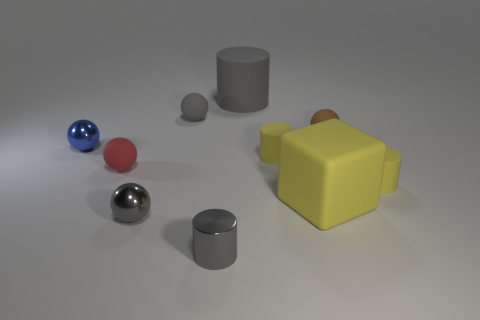There is a big object that is the same color as the metal cylinder; what material is it?
Give a very brief answer. Rubber. There is a matte object that is on the left side of the gray ball that is in front of the blue object; what is its shape?
Provide a succinct answer. Sphere. What number of other objects are the same material as the red ball?
Your answer should be compact. 6. Is the number of tiny yellow matte cylinders greater than the number of tiny red rubber cubes?
Your answer should be compact. Yes. How big is the gray cylinder that is behind the shiny sphere that is behind the tiny rubber thing that is on the left side of the tiny gray metallic ball?
Your response must be concise. Large. Is the size of the matte block the same as the gray cylinder behind the red sphere?
Provide a short and direct response. Yes. Is the number of tiny gray shiny cylinders that are right of the small gray matte object less than the number of big brown objects?
Ensure brevity in your answer.  No. What number of tiny matte objects are the same color as the metal cylinder?
Offer a terse response. 1. Is the number of tiny brown matte spheres less than the number of yellow rubber cylinders?
Keep it short and to the point. Yes. Is the tiny gray cylinder made of the same material as the large gray object?
Give a very brief answer. No. 